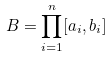Convert formula to latex. <formula><loc_0><loc_0><loc_500><loc_500>B = \prod _ { i = 1 } ^ { n } [ a _ { i } , b _ { i } ]</formula> 